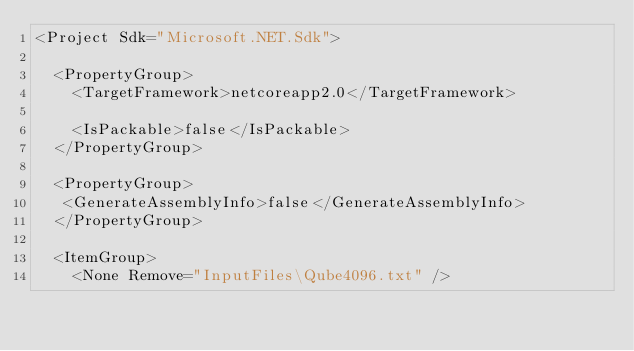Convert code to text. <code><loc_0><loc_0><loc_500><loc_500><_XML_><Project Sdk="Microsoft.NET.Sdk">

  <PropertyGroup>
    <TargetFramework>netcoreapp2.0</TargetFramework>

    <IsPackable>false</IsPackable>
  </PropertyGroup>

  <PropertyGroup>
   <GenerateAssemblyInfo>false</GenerateAssemblyInfo>
  </PropertyGroup> 
  
  <ItemGroup>
    <None Remove="InputFiles\Qube4096.txt" /></code> 